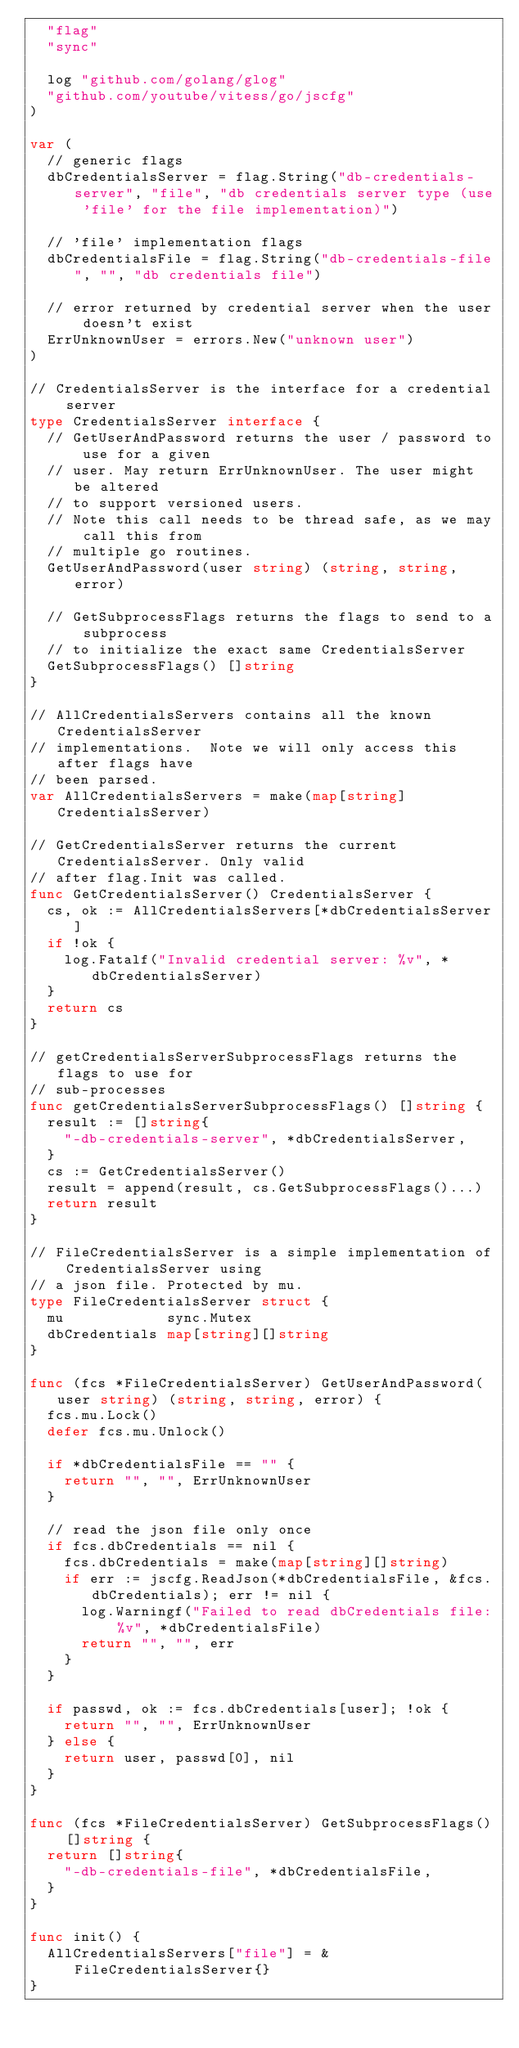Convert code to text. <code><loc_0><loc_0><loc_500><loc_500><_Go_>	"flag"
	"sync"

	log "github.com/golang/glog"
	"github.com/youtube/vitess/go/jscfg"
)

var (
	// generic flags
	dbCredentialsServer = flag.String("db-credentials-server", "file", "db credentials server type (use 'file' for the file implementation)")

	// 'file' implementation flags
	dbCredentialsFile = flag.String("db-credentials-file", "", "db credentials file")

	// error returned by credential server when the user doesn't exist
	ErrUnknownUser = errors.New("unknown user")
)

// CredentialsServer is the interface for a credential server
type CredentialsServer interface {
	// GetUserAndPassword returns the user / password to use for a given
	// user. May return ErrUnknownUser. The user might be altered
	// to support versioned users.
	// Note this call needs to be thread safe, as we may call this from
	// multiple go routines.
	GetUserAndPassword(user string) (string, string, error)

	// GetSubprocessFlags returns the flags to send to a subprocess
	// to initialize the exact same CredentialsServer
	GetSubprocessFlags() []string
}

// AllCredentialsServers contains all the known CredentialsServer
// implementations.  Note we will only access this after flags have
// been parsed.
var AllCredentialsServers = make(map[string]CredentialsServer)

// GetCredentialsServer returns the current CredentialsServer. Only valid
// after flag.Init was called.
func GetCredentialsServer() CredentialsServer {
	cs, ok := AllCredentialsServers[*dbCredentialsServer]
	if !ok {
		log.Fatalf("Invalid credential server: %v", *dbCredentialsServer)
	}
	return cs
}

// getCredentialsServerSubprocessFlags returns the flags to use for
// sub-processes
func getCredentialsServerSubprocessFlags() []string {
	result := []string{
		"-db-credentials-server", *dbCredentialsServer,
	}
	cs := GetCredentialsServer()
	result = append(result, cs.GetSubprocessFlags()...)
	return result
}

// FileCredentialsServer is a simple implementation of CredentialsServer using
// a json file. Protected by mu.
type FileCredentialsServer struct {
	mu            sync.Mutex
	dbCredentials map[string][]string
}

func (fcs *FileCredentialsServer) GetUserAndPassword(user string) (string, string, error) {
	fcs.mu.Lock()
	defer fcs.mu.Unlock()

	if *dbCredentialsFile == "" {
		return "", "", ErrUnknownUser
	}

	// read the json file only once
	if fcs.dbCredentials == nil {
		fcs.dbCredentials = make(map[string][]string)
		if err := jscfg.ReadJson(*dbCredentialsFile, &fcs.dbCredentials); err != nil {
			log.Warningf("Failed to read dbCredentials file: %v", *dbCredentialsFile)
			return "", "", err
		}
	}

	if passwd, ok := fcs.dbCredentials[user]; !ok {
		return "", "", ErrUnknownUser
	} else {
		return user, passwd[0], nil
	}
}

func (fcs *FileCredentialsServer) GetSubprocessFlags() []string {
	return []string{
		"-db-credentials-file", *dbCredentialsFile,
	}
}

func init() {
	AllCredentialsServers["file"] = &FileCredentialsServer{}
}
</code> 